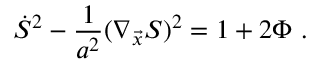Convert formula to latex. <formula><loc_0><loc_0><loc_500><loc_500>\dot { S } ^ { 2 } - { \frac { 1 } { a ^ { 2 } } } ( \nabla _ { \vec { x } } S ) ^ { 2 } = 1 + 2 \Phi \ .</formula> 